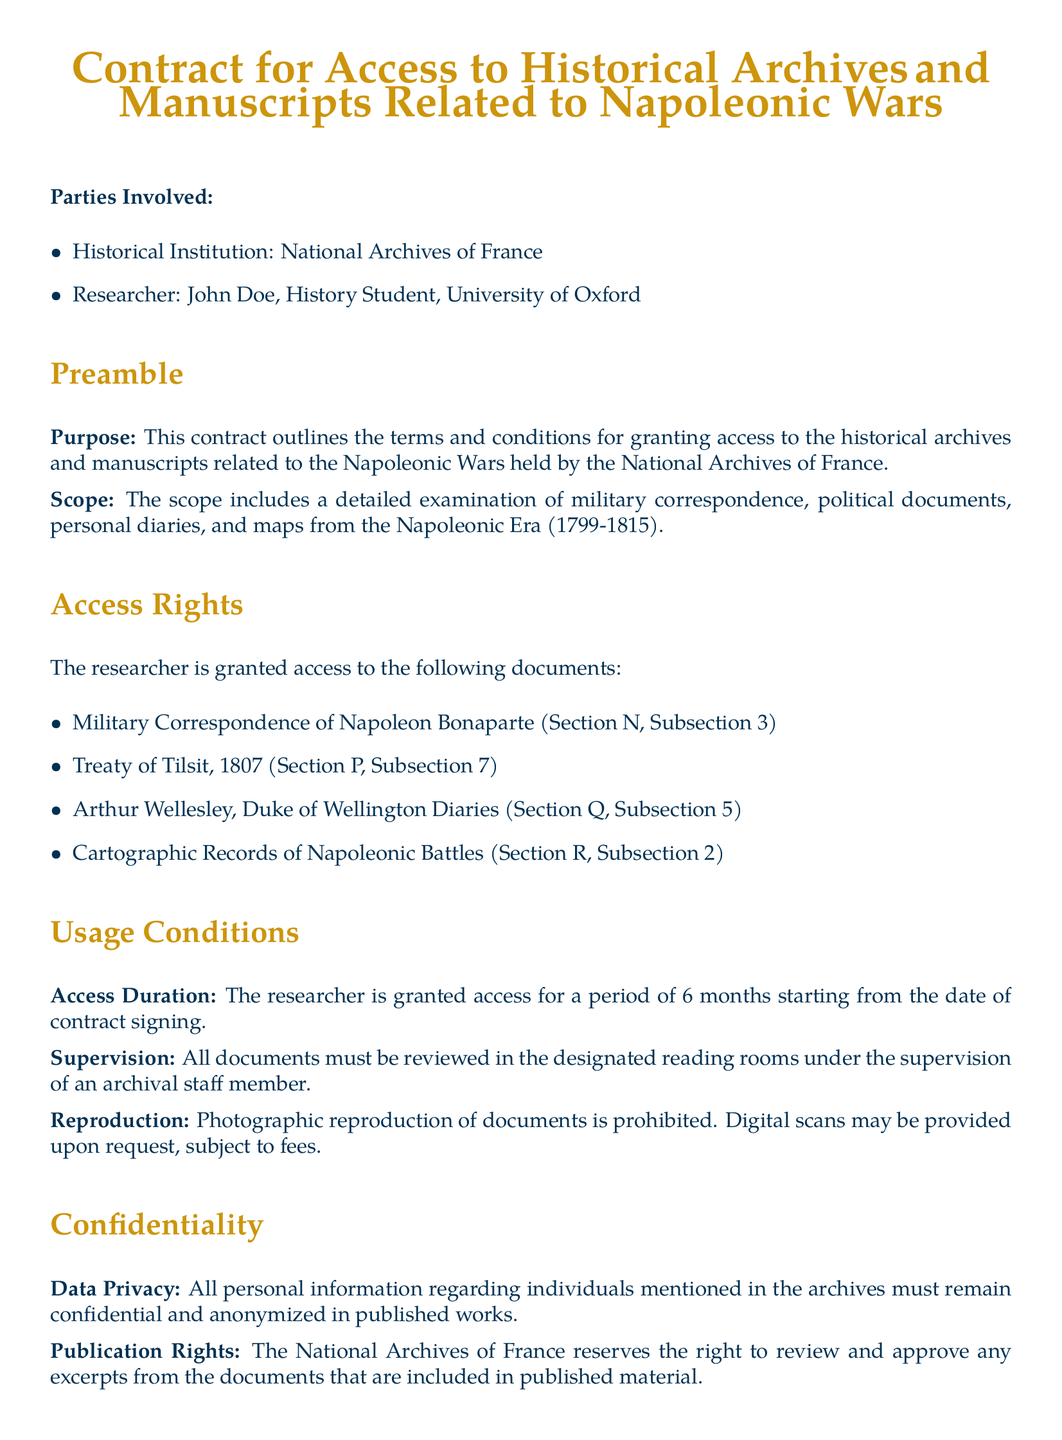What is the name of the historical institution? The historical institution mentioned in the document is the National Archives of France.
Answer: National Archives of France Who is the researcher named in the contract? The researcher named in the contract is John Doe.
Answer: John Doe For how long is access granted? The document states that access is granted for a period of 6 months starting from the date of contract signing.
Answer: 6 months What document is listed under Treaty of Tilsit? The specific document mentioned under Treaty of Tilsit is from the year 1807.
Answer: 1807 What must all documents be reviewed under? According to the document, all documents must be reviewed in the designated reading rooms under supervision.
Answer: Supervision What happens in case of a breach of terms? The document states that any violation of the terms will result in immediate revocation of access rights and potential legal action.
Answer: Immediate revocation and potential legal action What is prohibited regarding document reproduction? The contract specifies that photographic reproduction of documents is prohibited.
Answer: Photographic reproduction What is required for published material excerpts? The National Archives of France reserves the right to review and approve excerpts included in published material.
Answer: Review and approve What types of documents are included in the access rights? The access includes military correspondence, political documents, personal diaries, and maps from the Napoleonic Era.
Answer: Military correspondence, political documents, personal diaries, maps 